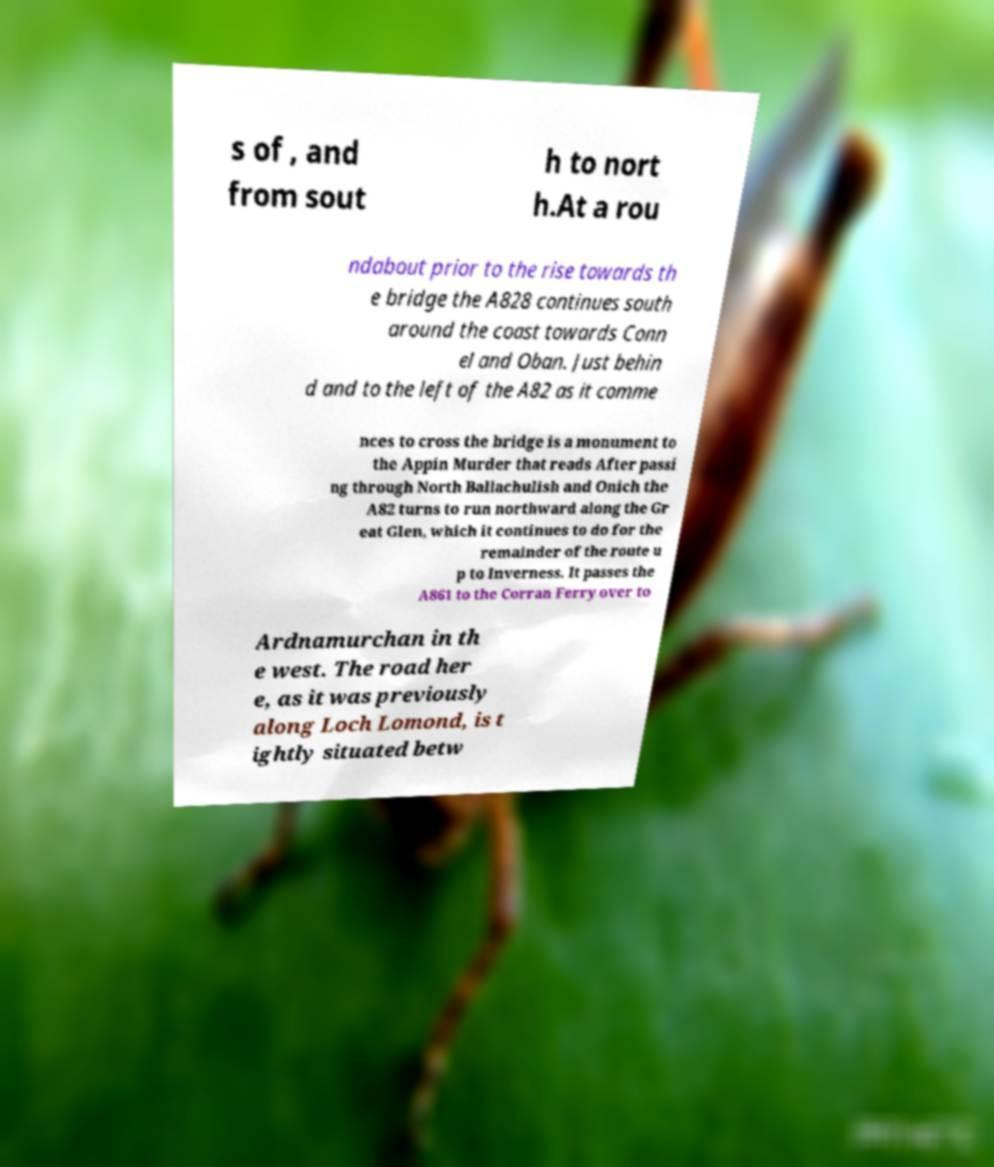Could you assist in decoding the text presented in this image and type it out clearly? s of , and from sout h to nort h.At a rou ndabout prior to the rise towards th e bridge the A828 continues south around the coast towards Conn el and Oban. Just behin d and to the left of the A82 as it comme nces to cross the bridge is a monument to the Appin Murder that reads After passi ng through North Ballachulish and Onich the A82 turns to run northward along the Gr eat Glen, which it continues to do for the remainder of the route u p to Inverness. It passes the A861 to the Corran Ferry over to Ardnamurchan in th e west. The road her e, as it was previously along Loch Lomond, is t ightly situated betw 